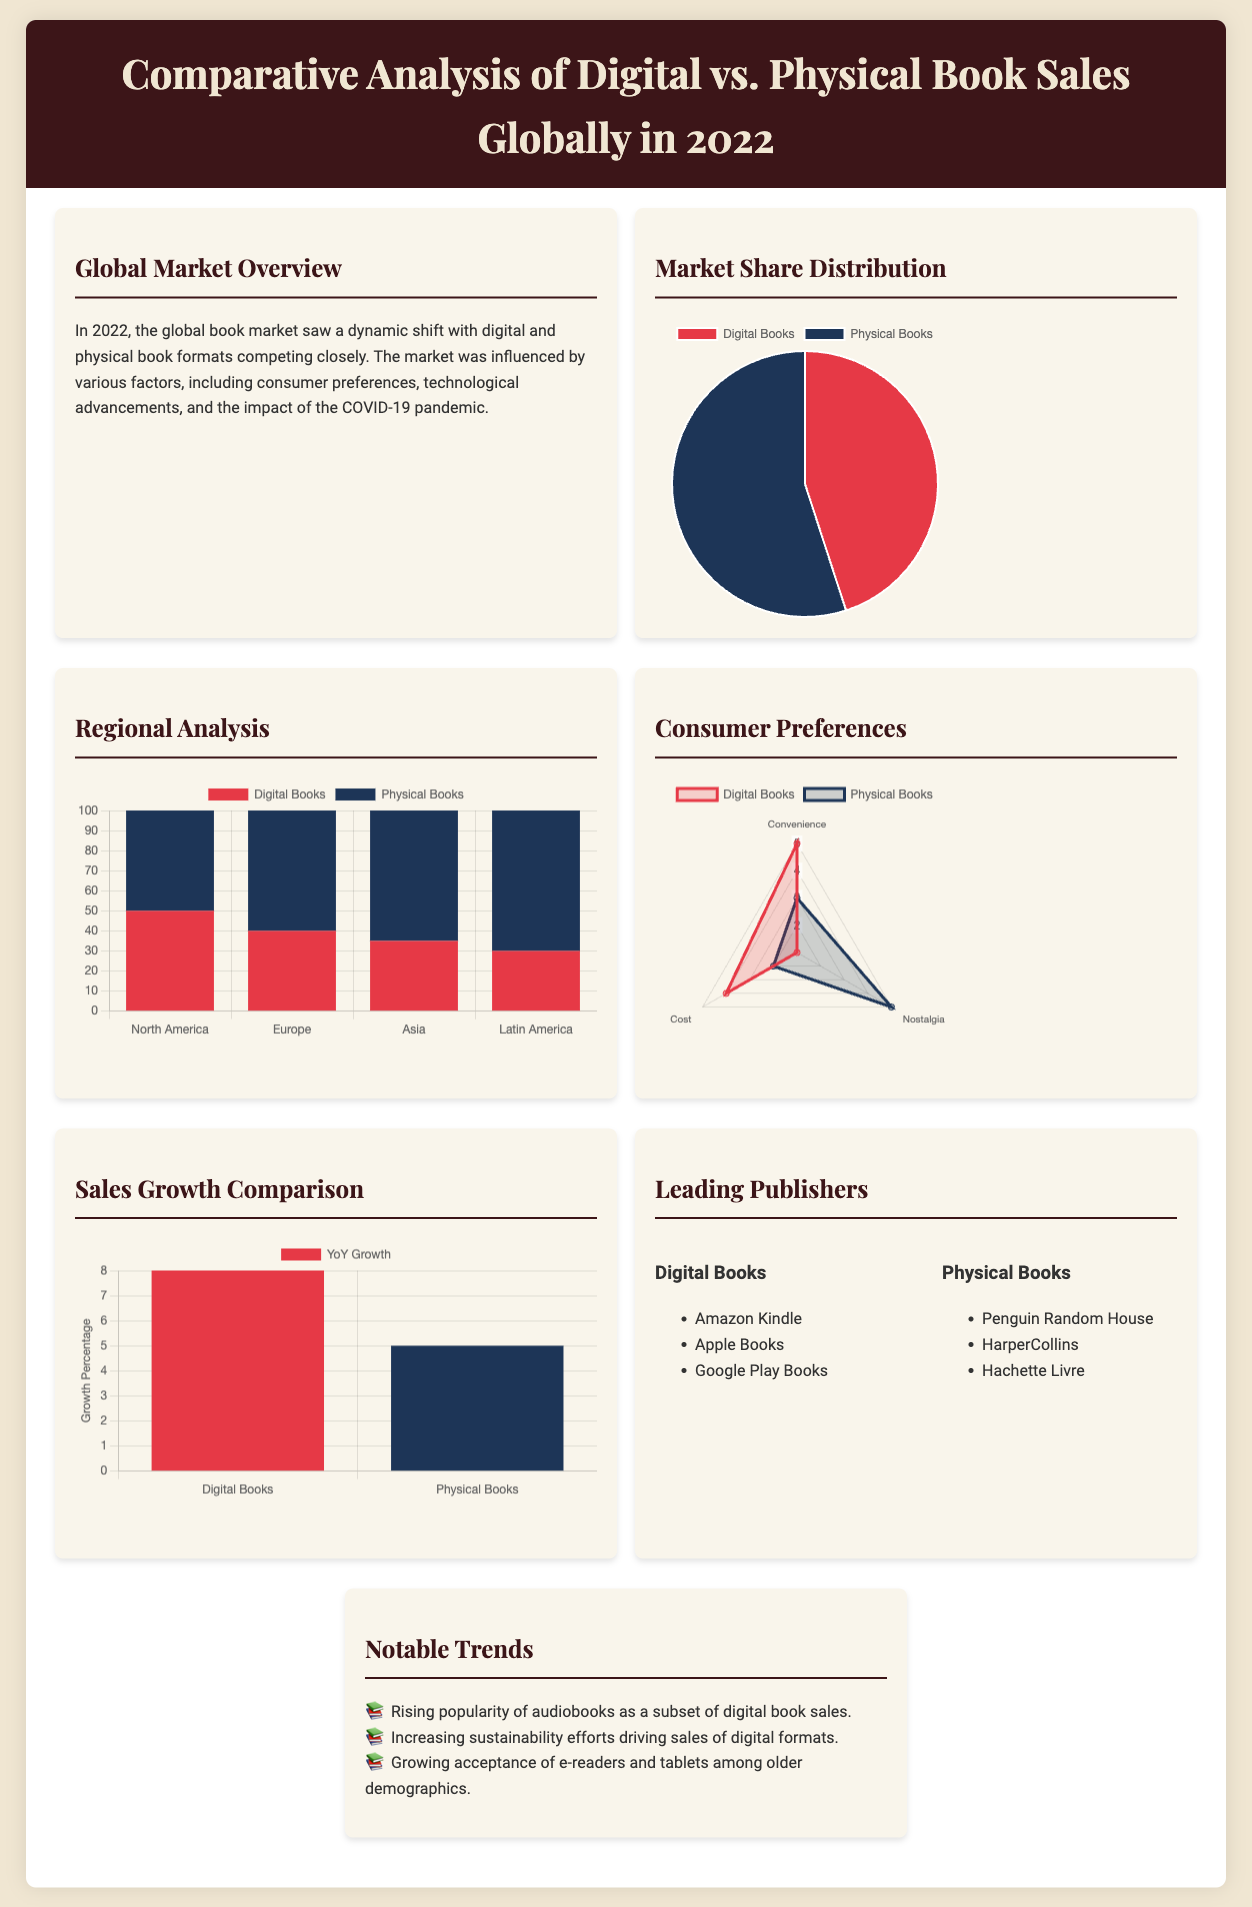What percentage of the market is attributed to digital books? The pie chart in the document shows that digital books hold a 45% share of the market.
Answer: 45% What is the YoY growth percentage for physical books? The sales growth comparison chart indicates that physical books have a year-over-year growth of 5%.
Answer: 5% Which region has the highest percentage of physical book sales? The bar chart shows that Latin America has the highest percentage of physical book sales at 70%.
Answer: 70% What major factor influenced the global book market in 2022? The document states that the market was influenced by factors such as consumer preferences and technological advancements.
Answer: Consumer preferences Which digital publisher is mentioned in the infographic? The leading publishers section lists Amazon Kindle as one of the digital book publishers.
Answer: Amazon Kindle In how many regions is the digital book sales data compared? The regional analysis chart compares digital book sales across four different regions.
Answer: Four What is the highest rating given for the convenience of digital books by consumers? The consumer preferences radar chart indicates that convenience for digital books is rated at 5.
Answer: 5 How many notable trends are listed in the document? The notable trends section of the document lists three key trends impacting the market.
Answer: Three What color represents physical books in the market share distribution chart? In the market share distribution chart, physical books are represented by the color blue.
Answer: Blue 